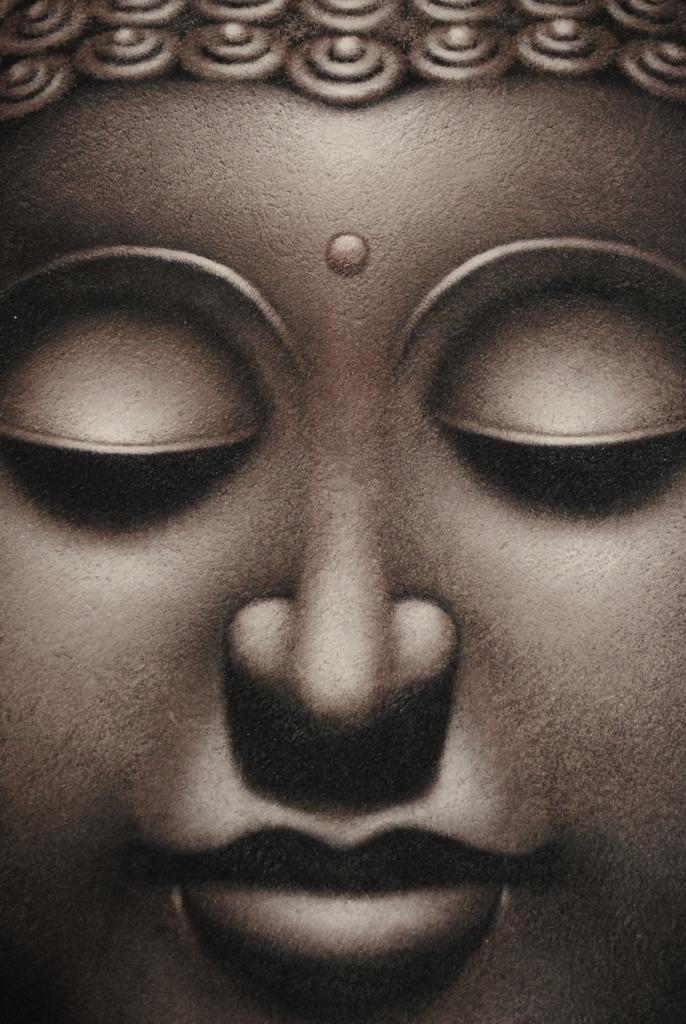What is the main subject of the image? The main subject of the image is a person's statue. What facial feature is not visible on the statue? The statue has closed eyes, so the eyes are not visible. What are some facial features that can be seen on the statue? The statue has a nose, a mouth, and cheeks. What type of sail can be seen on the statue's head? There is no sail present on the statue's head; it is a statue of a person and does not have any sail-like features. How many pies are placed on the statue's cheeks? There are no pies present on the statue's cheeks; the statue has cheeks as a facial feature, but they are not associated with pies. 